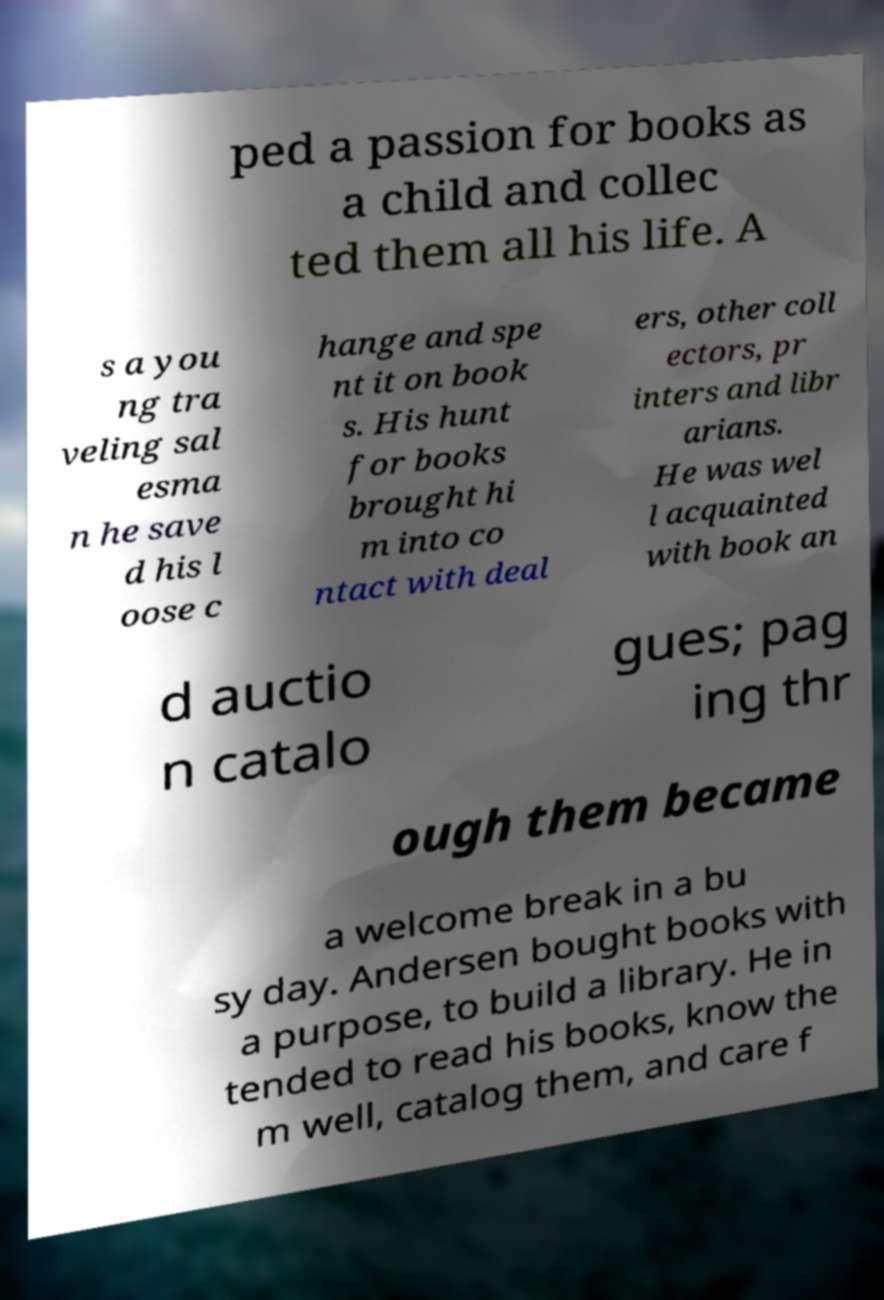For documentation purposes, I need the text within this image transcribed. Could you provide that? ped a passion for books as a child and collec ted them all his life. A s a you ng tra veling sal esma n he save d his l oose c hange and spe nt it on book s. His hunt for books brought hi m into co ntact with deal ers, other coll ectors, pr inters and libr arians. He was wel l acquainted with book an d auctio n catalo gues; pag ing thr ough them became a welcome break in a bu sy day. Andersen bought books with a purpose, to build a library. He in tended to read his books, know the m well, catalog them, and care f 